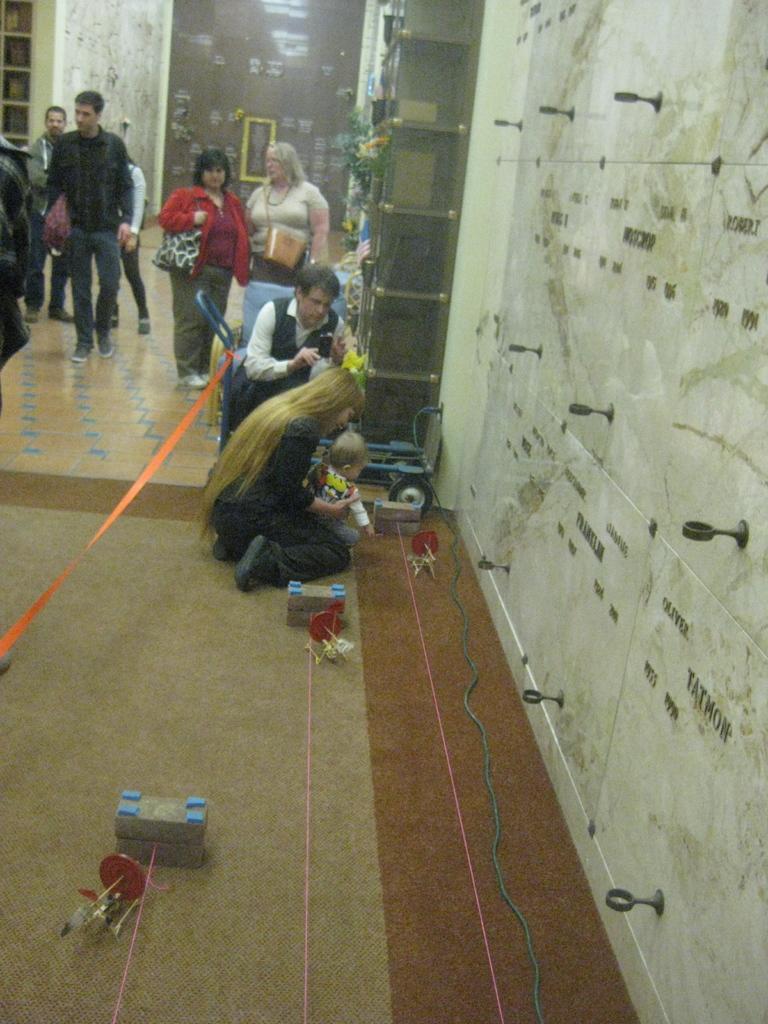In one or two sentences, can you explain what this image depicts? In this image we can see a group of people on the floor. In that a woman is sitting on her knees holding a baby. We can also see a ribbon tied to a chair, some objects with ropes placed on the floor, a photo frame on a wall and the racks. We can also see the metal handles and some text on a wall. 